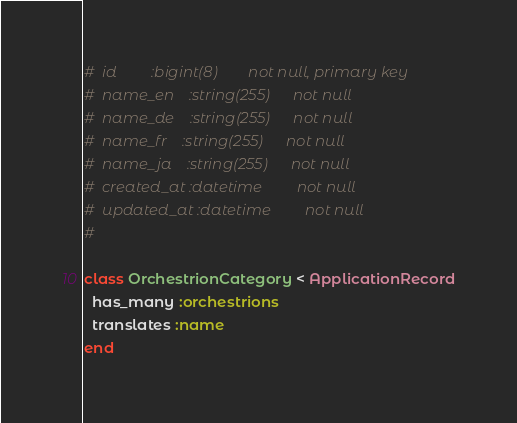<code> <loc_0><loc_0><loc_500><loc_500><_Ruby_>#  id         :bigint(8)        not null, primary key
#  name_en    :string(255)      not null
#  name_de    :string(255)      not null
#  name_fr    :string(255)      not null
#  name_ja    :string(255)      not null
#  created_at :datetime         not null
#  updated_at :datetime         not null
#

class OrchestrionCategory < ApplicationRecord
  has_many :orchestrions
  translates :name
end
</code> 